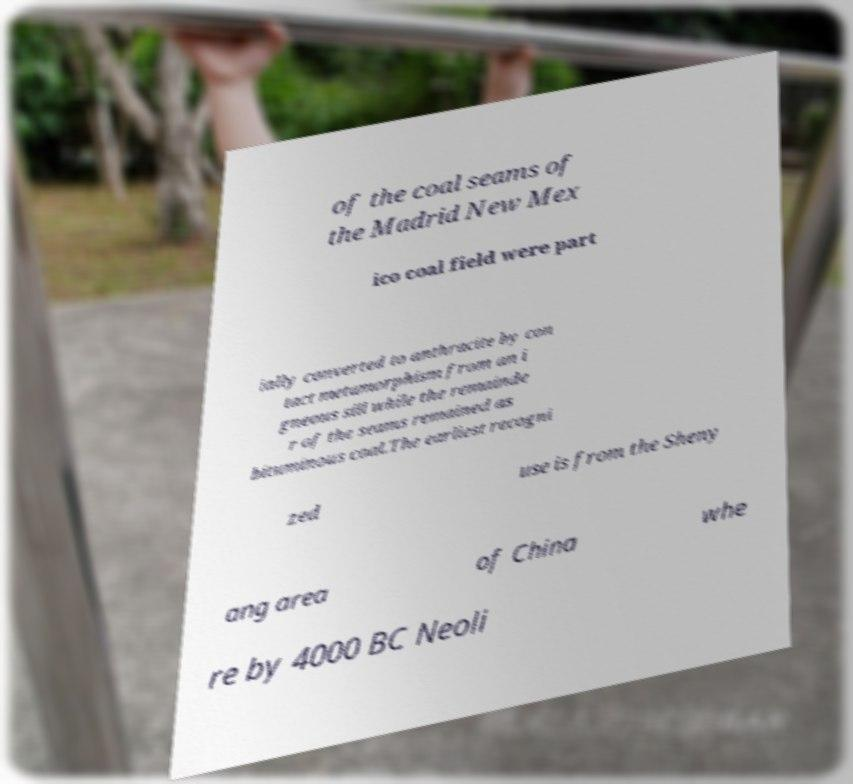Can you read and provide the text displayed in the image?This photo seems to have some interesting text. Can you extract and type it out for me? of the coal seams of the Madrid New Mex ico coal field were part ially converted to anthracite by con tact metamorphism from an i gneous sill while the remainde r of the seams remained as bituminous coal.The earliest recogni zed use is from the Sheny ang area of China whe re by 4000 BC Neoli 